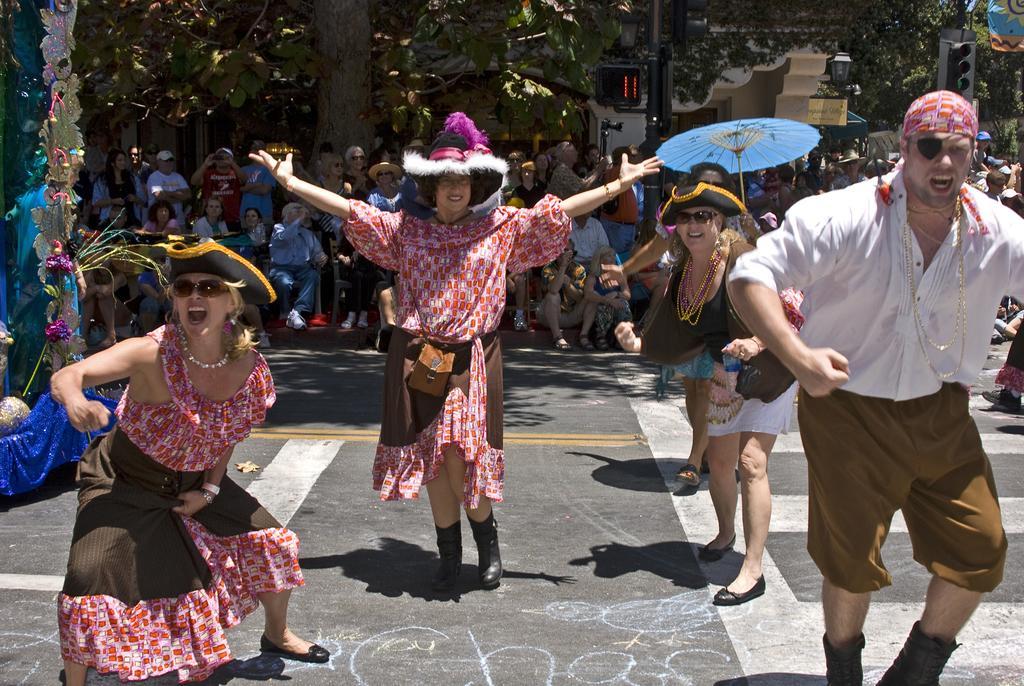In one or two sentences, can you explain what this image depicts? In this image in the foreground there are a group of people who are wearing some costumes, and it seems that they are dancing and they are wearing hats. And in the background there are a group of people who are sitting, and some of them are standing and watching them and also there are buildings, trees, lights, traffic signals and some other objects. At the bottom there is a road. 